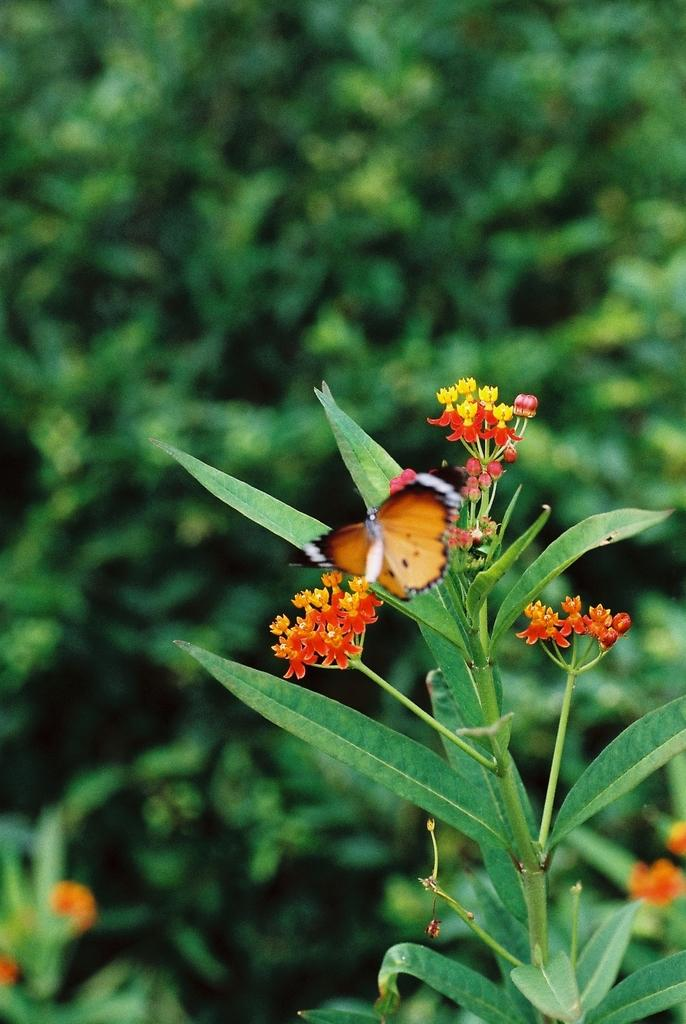What type of plant is visible in the image? There is a plant in the image, and it has leaves and flowers. What is present on the plant in the image? There is a butterfly on the plant in the image. What can be seen in the background of the image? There are many plants in the background of the image. What type of crayon can be seen in the image? There is no crayon present in the image. Is there a cave visible in the image? There is no cave present in the image. 